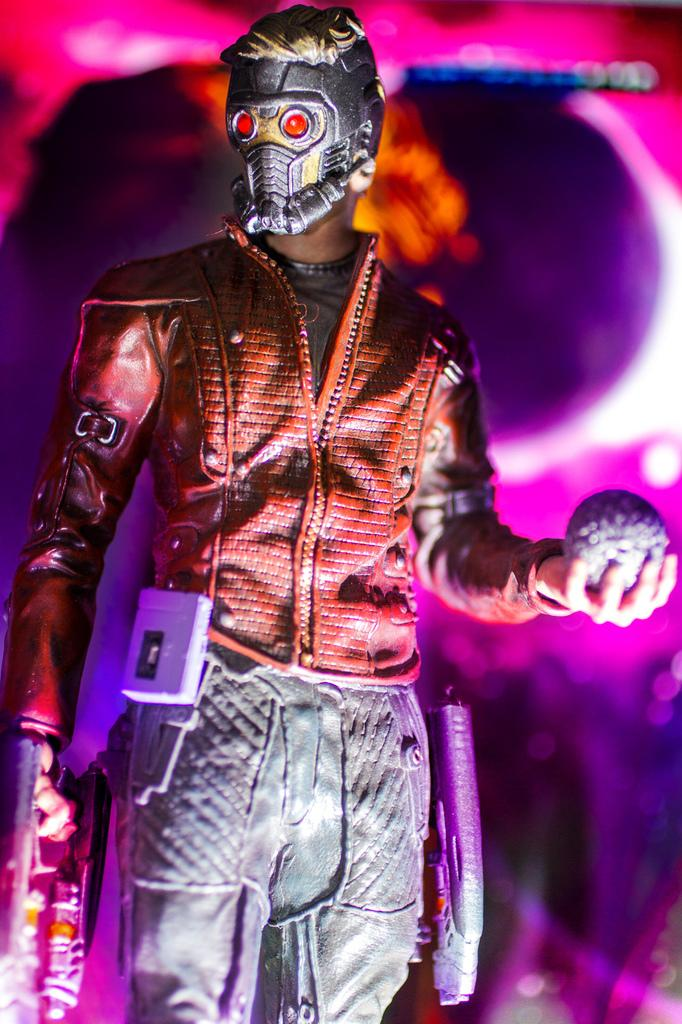Who or what is the main subject in the image? There is a person in the image. What is the person holding in their hand? The person is holding objects in their hand. Can you describe the person's appearance? The person is wearing a mask. What can be said about the background of the image? The background of the image is blurred. What type of duck can be seen interacting with the person in the image? There is no duck present in the image; the person is the main subject. Can you tell me how many goats are visible in the image? There are no goats present in the image. 